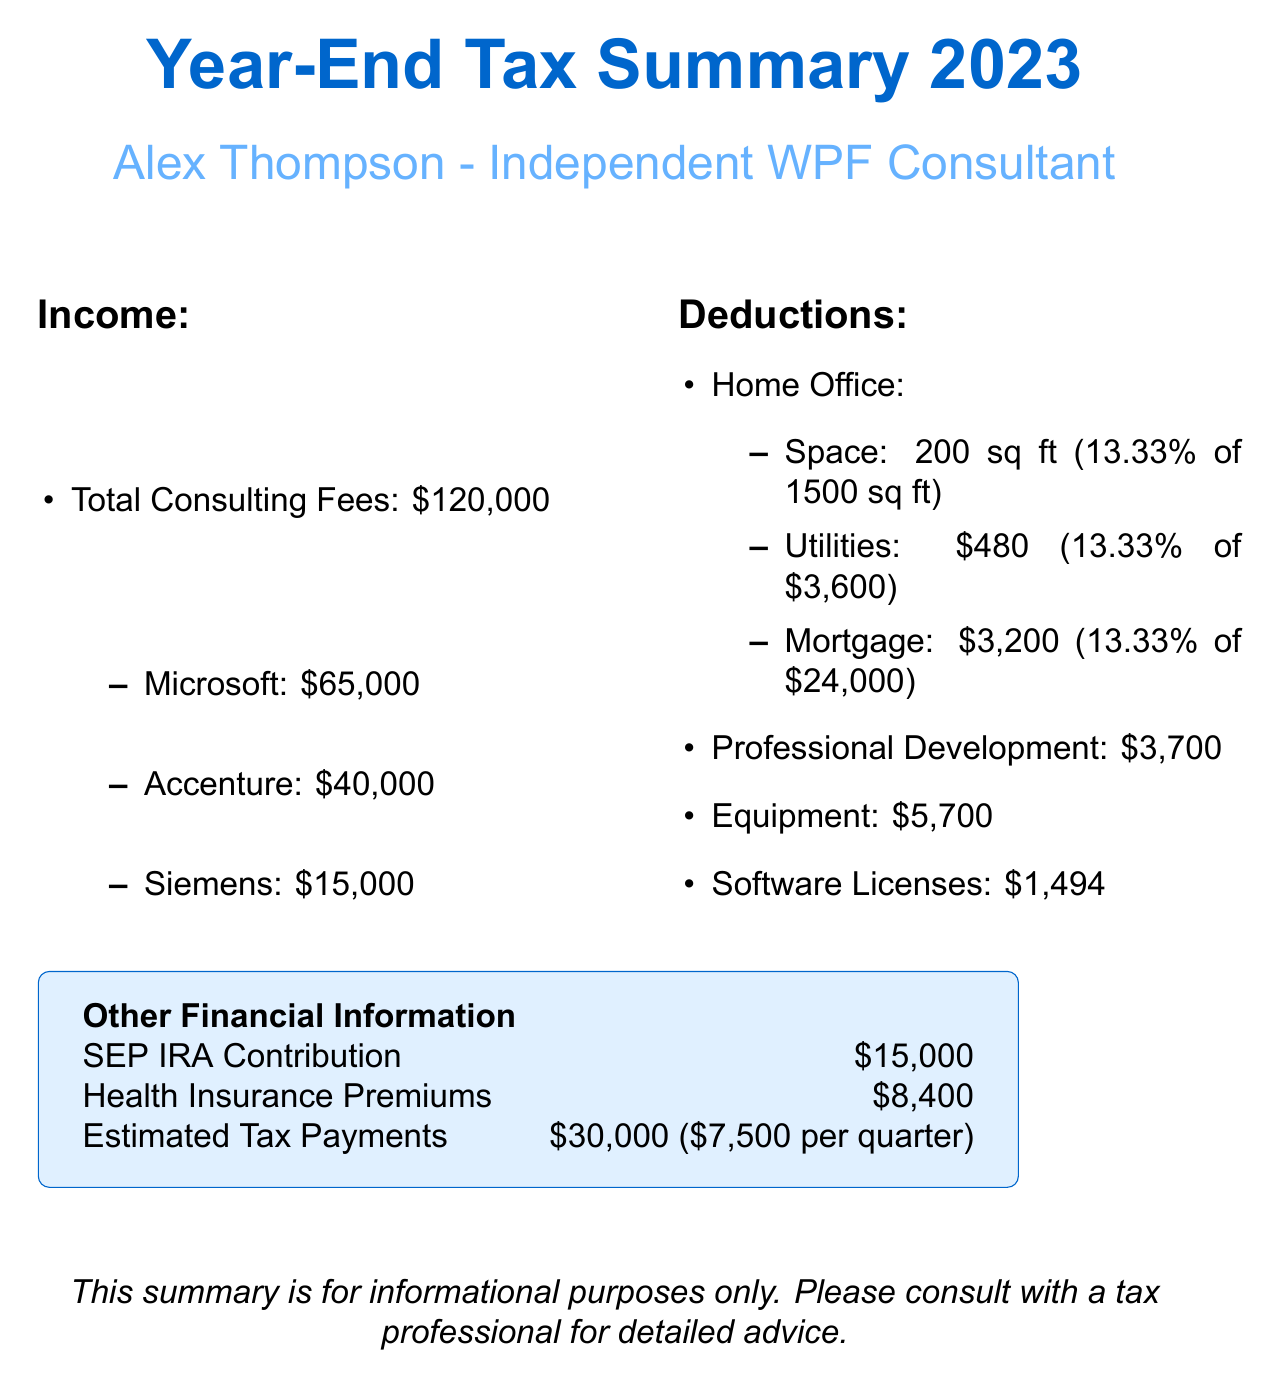what is the total consulting fees? The total consulting fees are listed as $120,000 in the document.
Answer: $120,000 how much did Alex earn from Microsoft? The earnings from Microsoft are specified as $65,000.
Answer: $65,000 what is the deduction for professional development? The total deduction for professional development courses is $3,700.
Answer: $3,700 what is the total amount for estimated tax payments? The document states that total estimated tax payments are $30,000.
Answer: $30,000 how much did Alex spend on software licenses? The total spent on software licenses is listed as $1,494.
Answer: $1,494 what percentage of the home is used for the home office? The document mentions that the home office is 13.33% of the total home square footage.
Answer: 13.33% how much is the SEP IRA contribution? The SEP IRA contribution is mentioned as $15,000 in the report.
Answer: $15,000 how much was spent on home office utilities? The amount spent on home office utilities is stated as $480.
Answer: $480 what is the total cost for equipment purchased? The total expenses for equipment are $5,700.
Answer: $5,700 